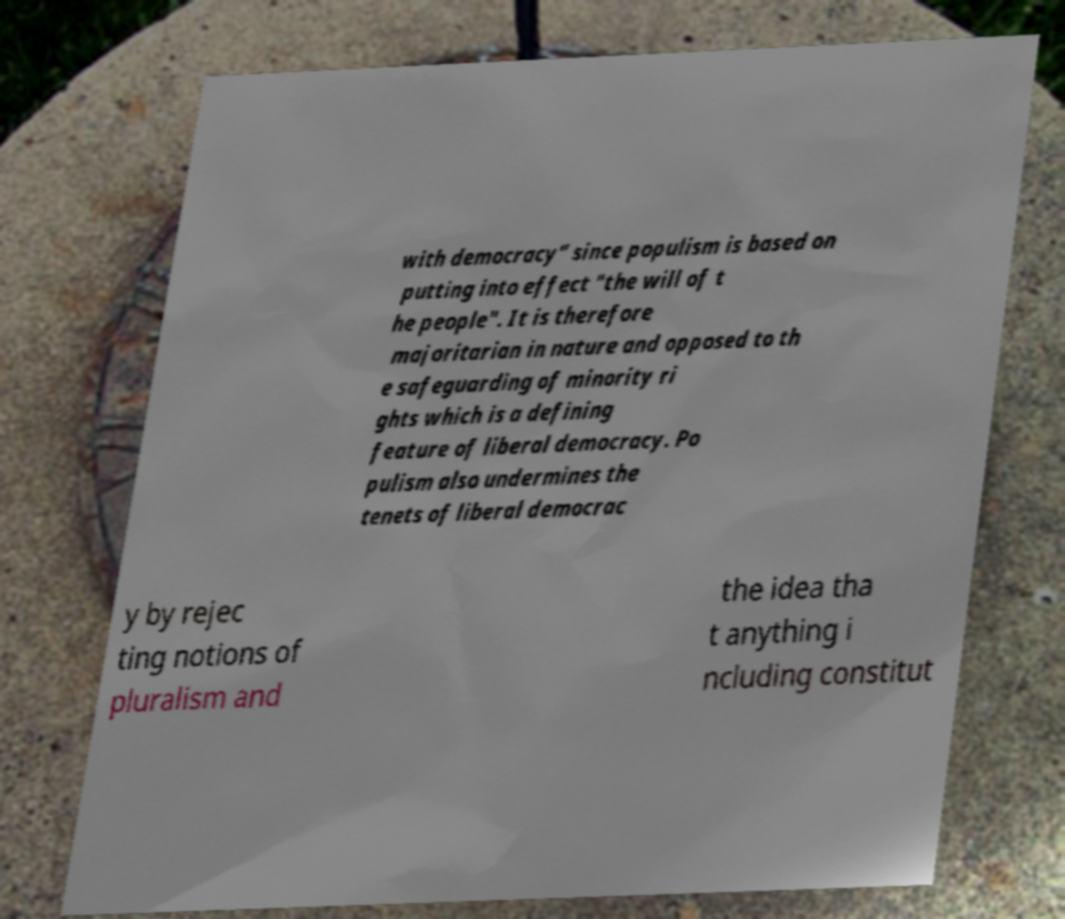For documentation purposes, I need the text within this image transcribed. Could you provide that? with democracy" since populism is based on putting into effect "the will of t he people". It is therefore majoritarian in nature and opposed to th e safeguarding of minority ri ghts which is a defining feature of liberal democracy. Po pulism also undermines the tenets of liberal democrac y by rejec ting notions of pluralism and the idea tha t anything i ncluding constitut 